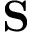<formula> <loc_0><loc_0><loc_500><loc_500>S</formula> 